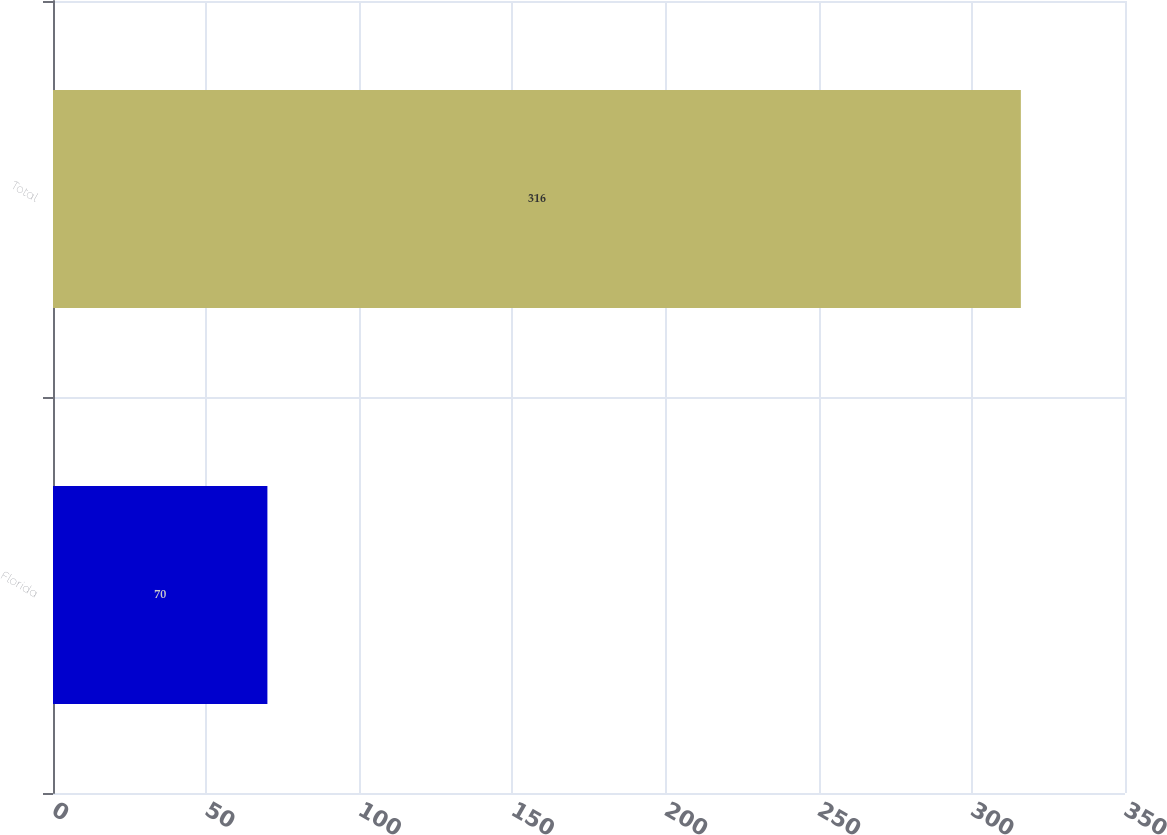Convert chart to OTSL. <chart><loc_0><loc_0><loc_500><loc_500><bar_chart><fcel>Florida<fcel>Total<nl><fcel>70<fcel>316<nl></chart> 